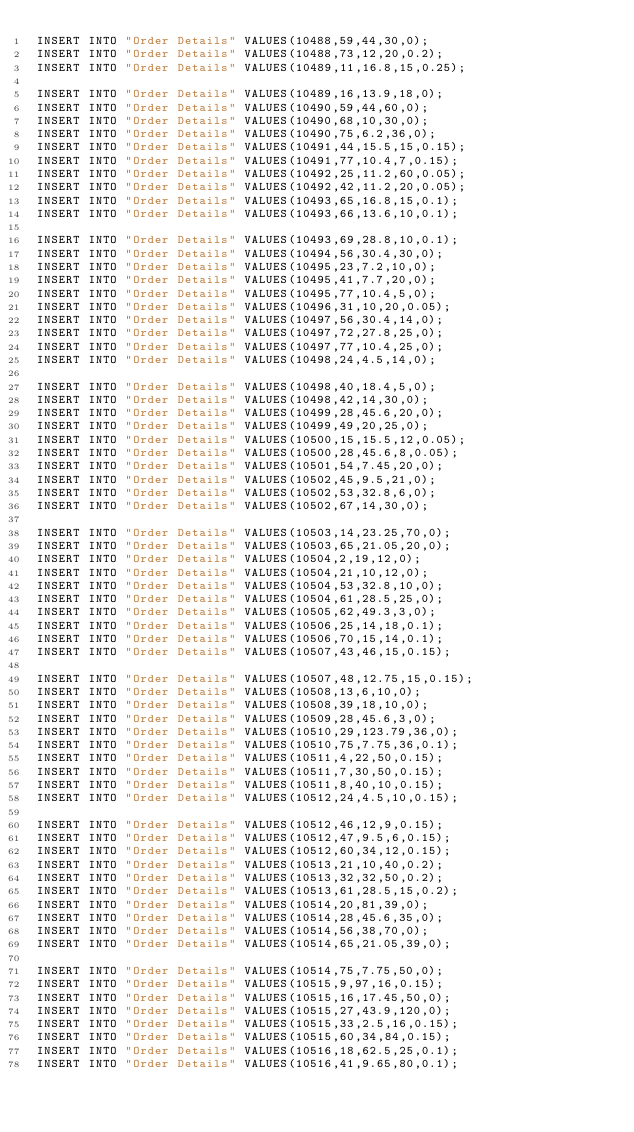<code> <loc_0><loc_0><loc_500><loc_500><_SQL_>INSERT INTO "Order Details" VALUES(10488,59,44,30,0);
INSERT INTO "Order Details" VALUES(10488,73,12,20,0.2);
INSERT INTO "Order Details" VALUES(10489,11,16.8,15,0.25);

INSERT INTO "Order Details" VALUES(10489,16,13.9,18,0);
INSERT INTO "Order Details" VALUES(10490,59,44,60,0);
INSERT INTO "Order Details" VALUES(10490,68,10,30,0);
INSERT INTO "Order Details" VALUES(10490,75,6.2,36,0);
INSERT INTO "Order Details" VALUES(10491,44,15.5,15,0.15);
INSERT INTO "Order Details" VALUES(10491,77,10.4,7,0.15);
INSERT INTO "Order Details" VALUES(10492,25,11.2,60,0.05);
INSERT INTO "Order Details" VALUES(10492,42,11.2,20,0.05);
INSERT INTO "Order Details" VALUES(10493,65,16.8,15,0.1);
INSERT INTO "Order Details" VALUES(10493,66,13.6,10,0.1);

INSERT INTO "Order Details" VALUES(10493,69,28.8,10,0.1);
INSERT INTO "Order Details" VALUES(10494,56,30.4,30,0);
INSERT INTO "Order Details" VALUES(10495,23,7.2,10,0);
INSERT INTO "Order Details" VALUES(10495,41,7.7,20,0);
INSERT INTO "Order Details" VALUES(10495,77,10.4,5,0);
INSERT INTO "Order Details" VALUES(10496,31,10,20,0.05);
INSERT INTO "Order Details" VALUES(10497,56,30.4,14,0);
INSERT INTO "Order Details" VALUES(10497,72,27.8,25,0);
INSERT INTO "Order Details" VALUES(10497,77,10.4,25,0);
INSERT INTO "Order Details" VALUES(10498,24,4.5,14,0);

INSERT INTO "Order Details" VALUES(10498,40,18.4,5,0);
INSERT INTO "Order Details" VALUES(10498,42,14,30,0);
INSERT INTO "Order Details" VALUES(10499,28,45.6,20,0);
INSERT INTO "Order Details" VALUES(10499,49,20,25,0);
INSERT INTO "Order Details" VALUES(10500,15,15.5,12,0.05);
INSERT INTO "Order Details" VALUES(10500,28,45.6,8,0.05);
INSERT INTO "Order Details" VALUES(10501,54,7.45,20,0);
INSERT INTO "Order Details" VALUES(10502,45,9.5,21,0);
INSERT INTO "Order Details" VALUES(10502,53,32.8,6,0);
INSERT INTO "Order Details" VALUES(10502,67,14,30,0);

INSERT INTO "Order Details" VALUES(10503,14,23.25,70,0);
INSERT INTO "Order Details" VALUES(10503,65,21.05,20,0);
INSERT INTO "Order Details" VALUES(10504,2,19,12,0);
INSERT INTO "Order Details" VALUES(10504,21,10,12,0);
INSERT INTO "Order Details" VALUES(10504,53,32.8,10,0);
INSERT INTO "Order Details" VALUES(10504,61,28.5,25,0);
INSERT INTO "Order Details" VALUES(10505,62,49.3,3,0);
INSERT INTO "Order Details" VALUES(10506,25,14,18,0.1);
INSERT INTO "Order Details" VALUES(10506,70,15,14,0.1);
INSERT INTO "Order Details" VALUES(10507,43,46,15,0.15);

INSERT INTO "Order Details" VALUES(10507,48,12.75,15,0.15);
INSERT INTO "Order Details" VALUES(10508,13,6,10,0);
INSERT INTO "Order Details" VALUES(10508,39,18,10,0);
INSERT INTO "Order Details" VALUES(10509,28,45.6,3,0);
INSERT INTO "Order Details" VALUES(10510,29,123.79,36,0);
INSERT INTO "Order Details" VALUES(10510,75,7.75,36,0.1);
INSERT INTO "Order Details" VALUES(10511,4,22,50,0.15);
INSERT INTO "Order Details" VALUES(10511,7,30,50,0.15);
INSERT INTO "Order Details" VALUES(10511,8,40,10,0.15);
INSERT INTO "Order Details" VALUES(10512,24,4.5,10,0.15);

INSERT INTO "Order Details" VALUES(10512,46,12,9,0.15);
INSERT INTO "Order Details" VALUES(10512,47,9.5,6,0.15);
INSERT INTO "Order Details" VALUES(10512,60,34,12,0.15);
INSERT INTO "Order Details" VALUES(10513,21,10,40,0.2);
INSERT INTO "Order Details" VALUES(10513,32,32,50,0.2);
INSERT INTO "Order Details" VALUES(10513,61,28.5,15,0.2);
INSERT INTO "Order Details" VALUES(10514,20,81,39,0);
INSERT INTO "Order Details" VALUES(10514,28,45.6,35,0);
INSERT INTO "Order Details" VALUES(10514,56,38,70,0);
INSERT INTO "Order Details" VALUES(10514,65,21.05,39,0);

INSERT INTO "Order Details" VALUES(10514,75,7.75,50,0);
INSERT INTO "Order Details" VALUES(10515,9,97,16,0.15);
INSERT INTO "Order Details" VALUES(10515,16,17.45,50,0);
INSERT INTO "Order Details" VALUES(10515,27,43.9,120,0);
INSERT INTO "Order Details" VALUES(10515,33,2.5,16,0.15);
INSERT INTO "Order Details" VALUES(10515,60,34,84,0.15);
INSERT INTO "Order Details" VALUES(10516,18,62.5,25,0.1);
INSERT INTO "Order Details" VALUES(10516,41,9.65,80,0.1);</code> 